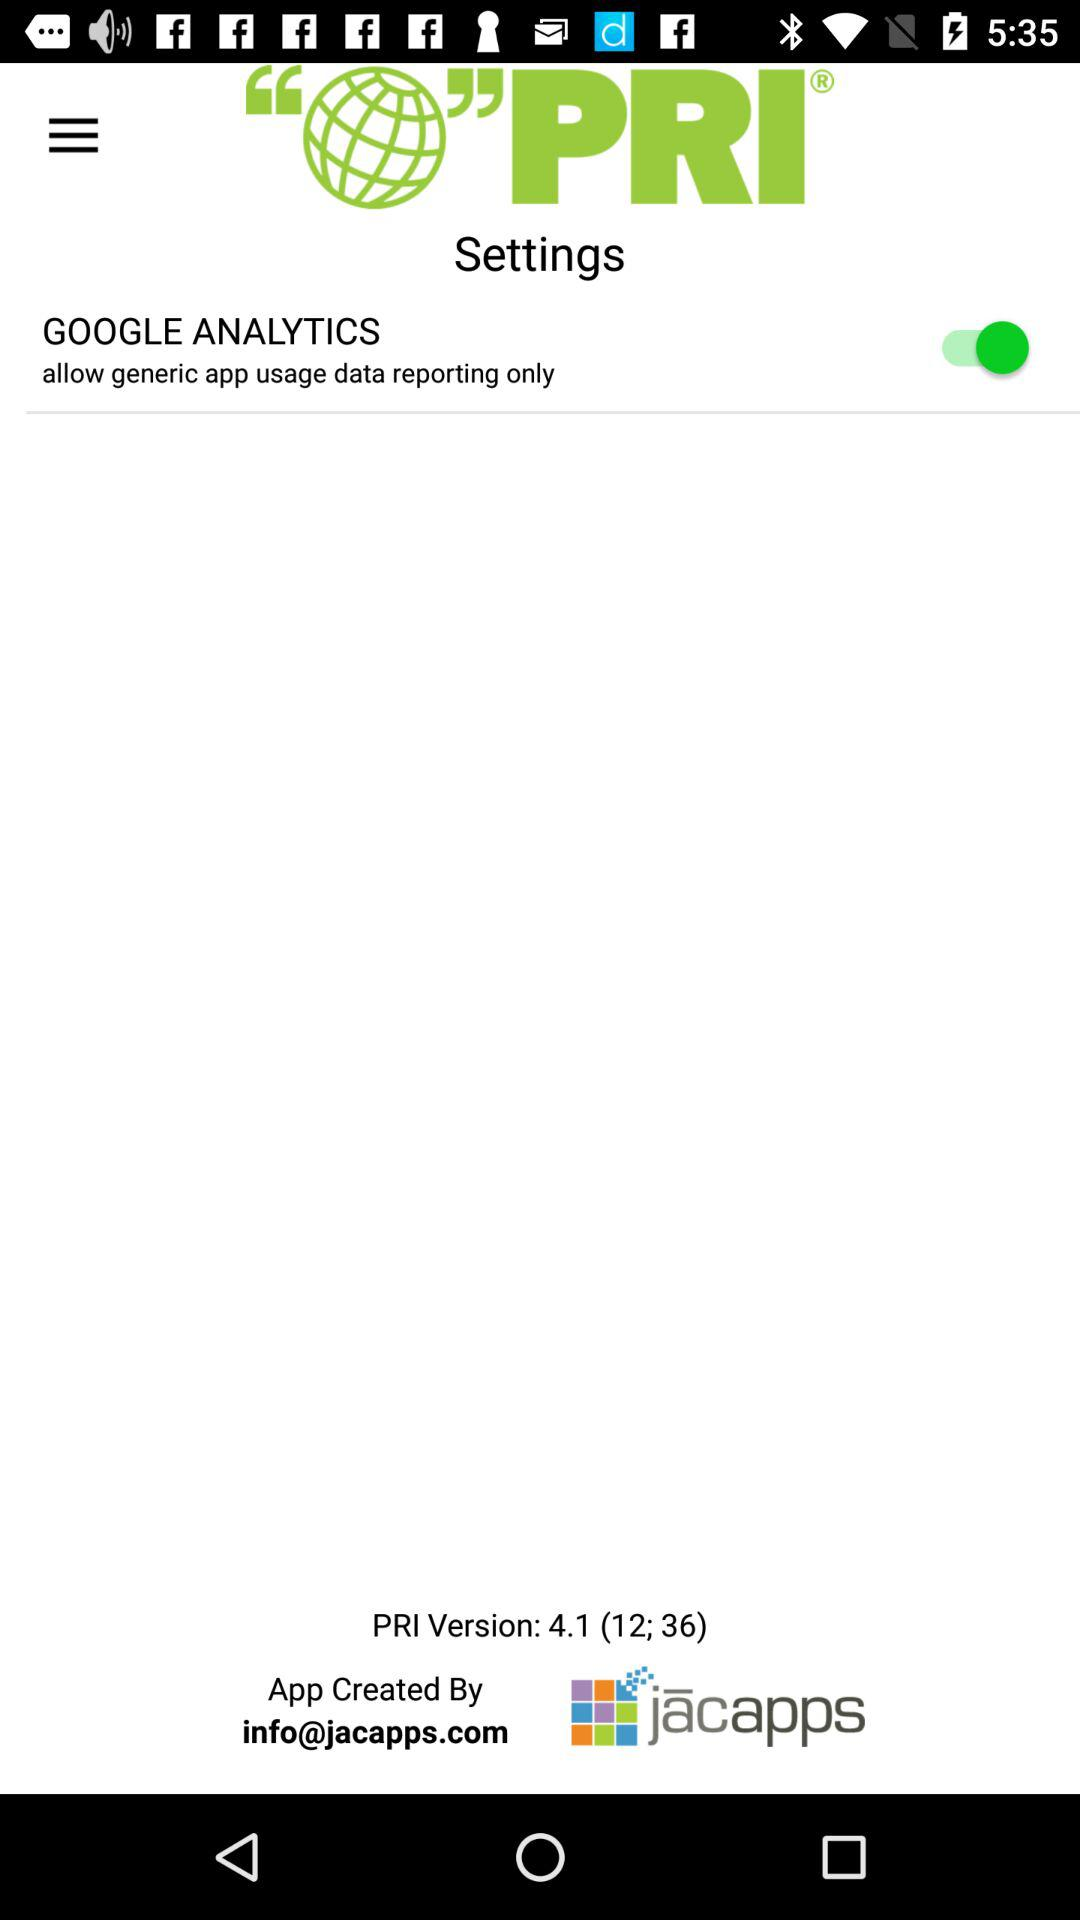Who created the application? The application was created by "jācapps". 